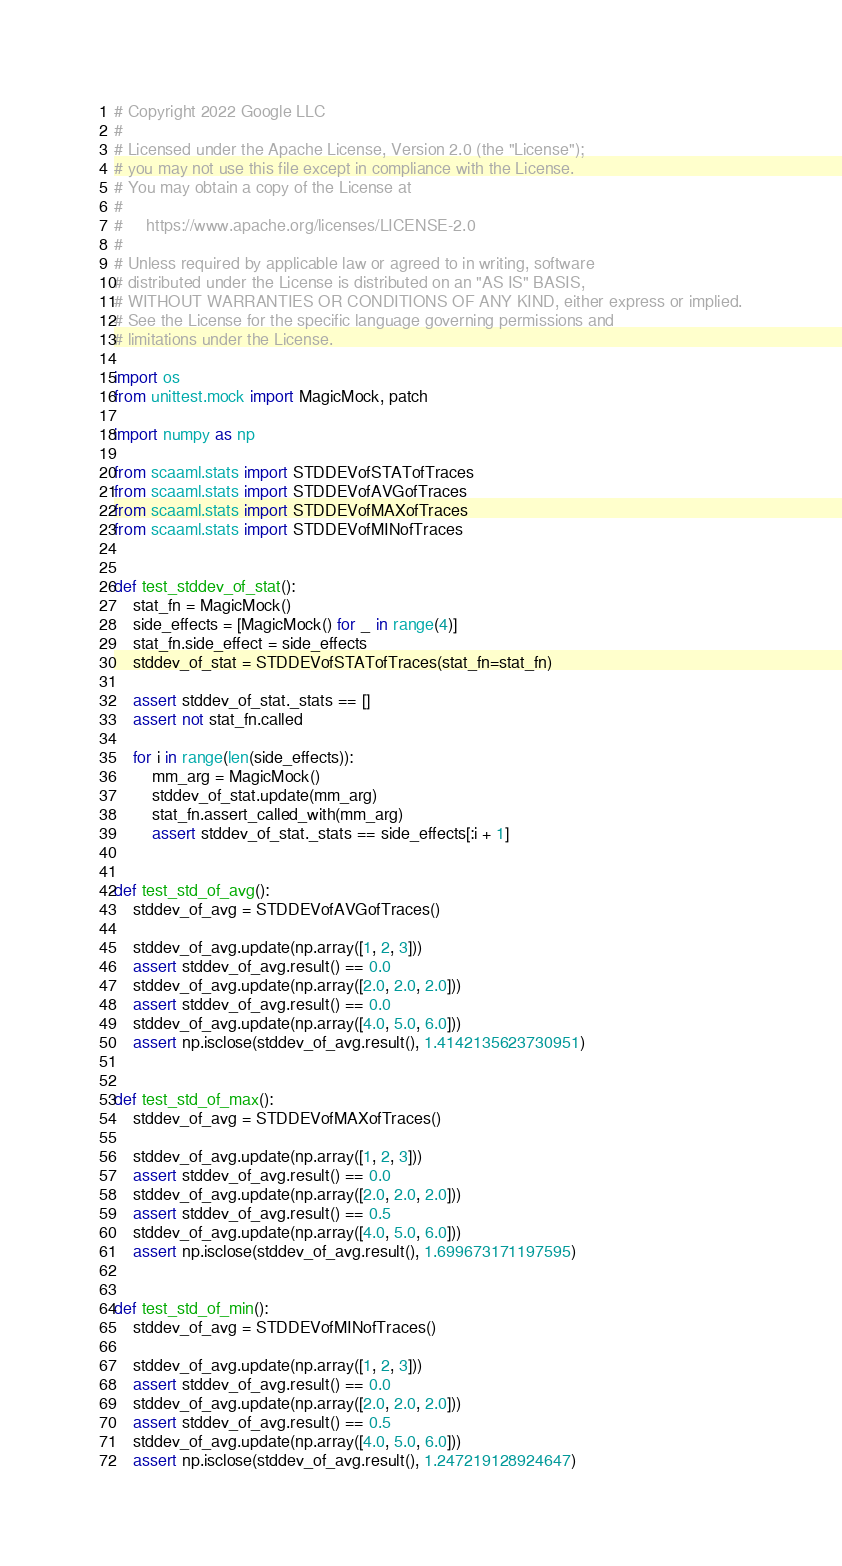<code> <loc_0><loc_0><loc_500><loc_500><_Python_># Copyright 2022 Google LLC
#
# Licensed under the Apache License, Version 2.0 (the "License");
# you may not use this file except in compliance with the License.
# You may obtain a copy of the License at
#
#     https://www.apache.org/licenses/LICENSE-2.0
#
# Unless required by applicable law or agreed to in writing, software
# distributed under the License is distributed on an "AS IS" BASIS,
# WITHOUT WARRANTIES OR CONDITIONS OF ANY KIND, either express or implied.
# See the License for the specific language governing permissions and
# limitations under the License.

import os
from unittest.mock import MagicMock, patch

import numpy as np

from scaaml.stats import STDDEVofSTATofTraces
from scaaml.stats import STDDEVofAVGofTraces
from scaaml.stats import STDDEVofMAXofTraces
from scaaml.stats import STDDEVofMINofTraces


def test_stddev_of_stat():
    stat_fn = MagicMock()
    side_effects = [MagicMock() for _ in range(4)]
    stat_fn.side_effect = side_effects
    stddev_of_stat = STDDEVofSTATofTraces(stat_fn=stat_fn)

    assert stddev_of_stat._stats == []
    assert not stat_fn.called

    for i in range(len(side_effects)):
        mm_arg = MagicMock()
        stddev_of_stat.update(mm_arg)
        stat_fn.assert_called_with(mm_arg)
        assert stddev_of_stat._stats == side_effects[:i + 1]


def test_std_of_avg():
    stddev_of_avg = STDDEVofAVGofTraces()

    stddev_of_avg.update(np.array([1, 2, 3]))
    assert stddev_of_avg.result() == 0.0
    stddev_of_avg.update(np.array([2.0, 2.0, 2.0]))
    assert stddev_of_avg.result() == 0.0
    stddev_of_avg.update(np.array([4.0, 5.0, 6.0]))
    assert np.isclose(stddev_of_avg.result(), 1.4142135623730951)


def test_std_of_max():
    stddev_of_avg = STDDEVofMAXofTraces()

    stddev_of_avg.update(np.array([1, 2, 3]))
    assert stddev_of_avg.result() == 0.0
    stddev_of_avg.update(np.array([2.0, 2.0, 2.0]))
    assert stddev_of_avg.result() == 0.5
    stddev_of_avg.update(np.array([4.0, 5.0, 6.0]))
    assert np.isclose(stddev_of_avg.result(), 1.699673171197595)


def test_std_of_min():
    stddev_of_avg = STDDEVofMINofTraces()

    stddev_of_avg.update(np.array([1, 2, 3]))
    assert stddev_of_avg.result() == 0.0
    stddev_of_avg.update(np.array([2.0, 2.0, 2.0]))
    assert stddev_of_avg.result() == 0.5
    stddev_of_avg.update(np.array([4.0, 5.0, 6.0]))
    assert np.isclose(stddev_of_avg.result(), 1.247219128924647)
</code> 